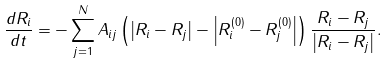Convert formula to latex. <formula><loc_0><loc_0><loc_500><loc_500>\frac { d R _ { i } } { d t } = - \sum _ { j = 1 } ^ { N } A _ { i j } \left ( \left | R _ { i } - R _ { j } \right | - \left | R _ { i } ^ { ( 0 ) } - R _ { j } ^ { ( 0 ) } \right | \right ) \frac { R _ { i } - R _ { j } } { \left | R _ { i } - R _ { j } \right | } .</formula> 